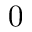<formula> <loc_0><loc_0><loc_500><loc_500>0</formula> 